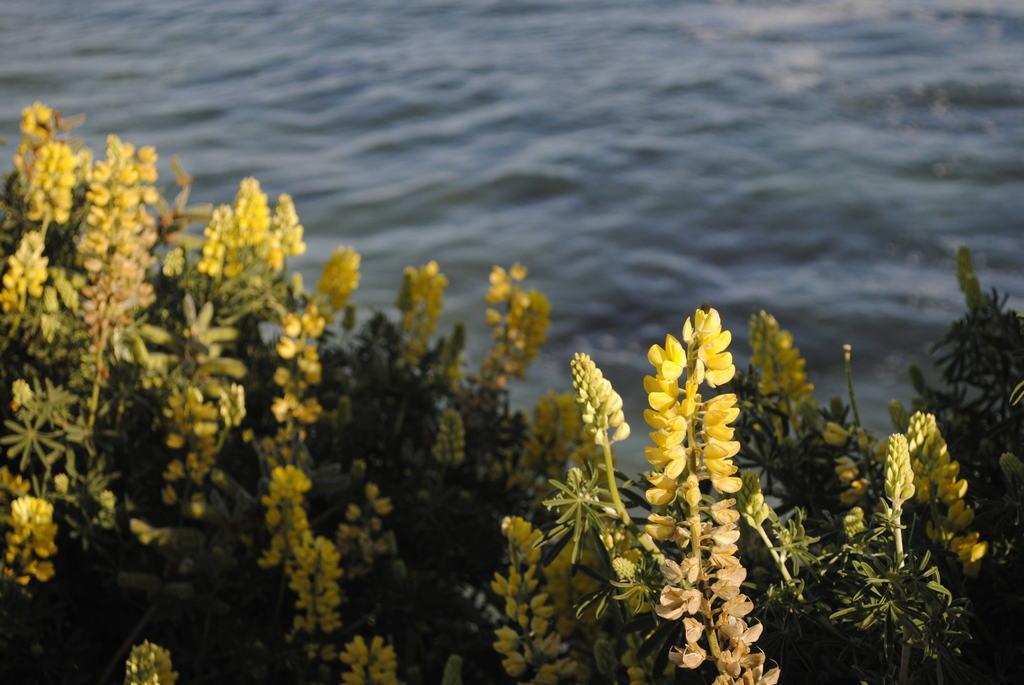Could you give a brief overview of what you see in this image? In this image I can see yellow colour flowers, buds and green colour leaves. I can also see water in the background. 